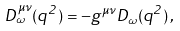Convert formula to latex. <formula><loc_0><loc_0><loc_500><loc_500>D _ { \omega } ^ { \mu \nu } ( q ^ { 2 } ) = - g ^ { \mu \nu } D _ { \omega } ( q ^ { 2 } ) \, ,</formula> 